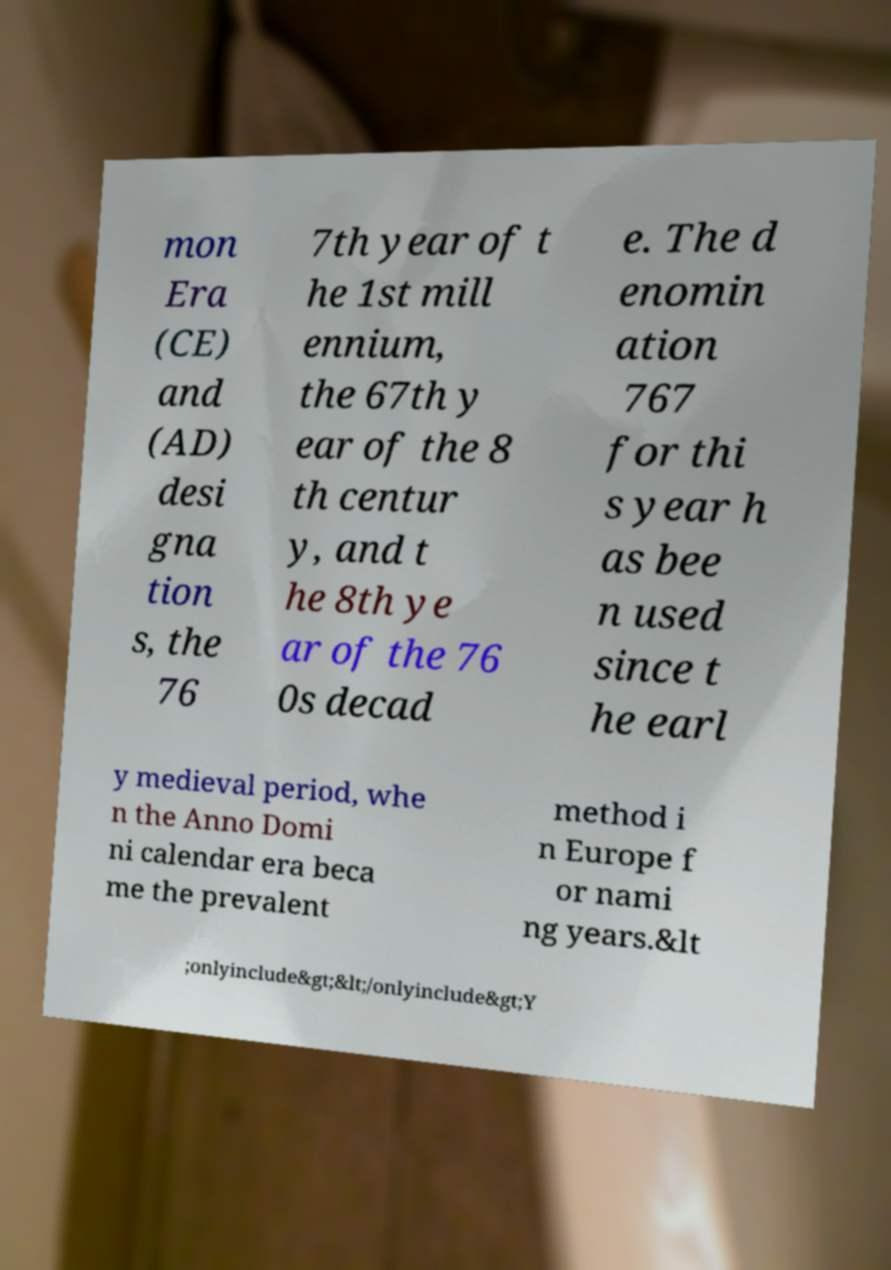Please identify and transcribe the text found in this image. mon Era (CE) and (AD) desi gna tion s, the 76 7th year of t he 1st mill ennium, the 67th y ear of the 8 th centur y, and t he 8th ye ar of the 76 0s decad e. The d enomin ation 767 for thi s year h as bee n used since t he earl y medieval period, whe n the Anno Domi ni calendar era beca me the prevalent method i n Europe f or nami ng years.&lt ;onlyinclude&gt;&lt;/onlyinclude&gt;Y 